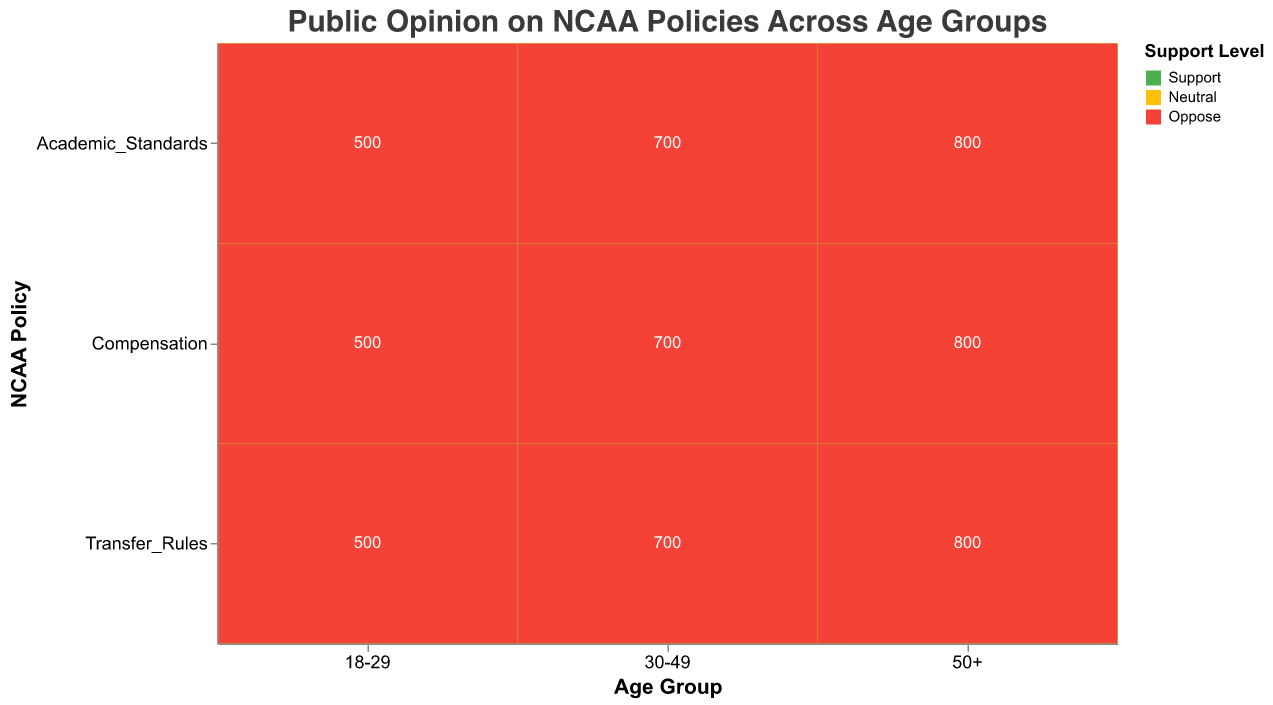What is the title of the figure? The title is displayed at the top of the figure and provides a summary of what the figure is about. It reads: "Public Opinion on NCAA Policies Across Age Groups."
Answer: Public Opinion on NCAA Policies Across Age Groups Which age group shows the highest support for compensation policies? Look for the "Support" section in the "Compensation" row and compare the height of the bars across different age groups. The largest bar in the "Support" section belongs to the "30-49" age group.
Answer: 30-49 What is the total count of people aged 50+ who have a neutral opinion on transfer rules? Find the "Transfer_Rules" row and within it, look for the "Neutral" section under the "50+" age group. The count is displayed in this area.
Answer: 300 Which policy has the least opposition level among the 18-29 age group? In the row corresponding to each NCAA policy, compare the heights of the bars in the "Oppose" section for the "18-29" age group. The shortest bar indicates the least opposition. The "Transfer_Rules" policy has the shortest bar in this section.
Answer: Transfer Rules Compare the support levels for academic standards between the 30-49 and 50+ age groups. Which age group has higher support? Locate the "Academic_Standards" row and compare the height of the bars in the "Support" section for the "30-49" and "50+" age groups. The "50+" age group shows a higher support level.
Answer: 50+ What is the total number of people aged 18-29 who support, oppose, or are neutral towards the compensation policy? Summing up the counts in the "Compensation" row for the "18-29" age group across all support levels gives: 280 (Support) + 120 (Neutral) + 100 (Oppose) = 500.
Answer: 500 How does opposition for transfer rules change across different age groups? Observe the "Transfer_Rules" row and compare the heights of the "Oppose" sections for each age group. The opposition level shows an increasing trend as the age group shifts from "18-29" (60) to "30-49" (100) and then significantly higher to "50+" (320).
Answer: Increasing Which policy has the most support from the 18-29 age group? Compare the heights of the "Support" sections across all policies for the "18-29" age group. The "Transfer_Rules" policy has the highest bar, indicating the most support.
Answer: Transfer Rules Identify the relative proportions of support, neutral, and opposition for academic standards among the 30-49 age group? In the "Academic_Standards" row, look at the "30-49" age group and observe the respective proportions of the bars for "Support" (300), "Neutral" (250), and "Oppose" (150). The Support proportion is the largest, followed by Neutral and then Oppose.
Answer: Support > Neutral > Oppose 